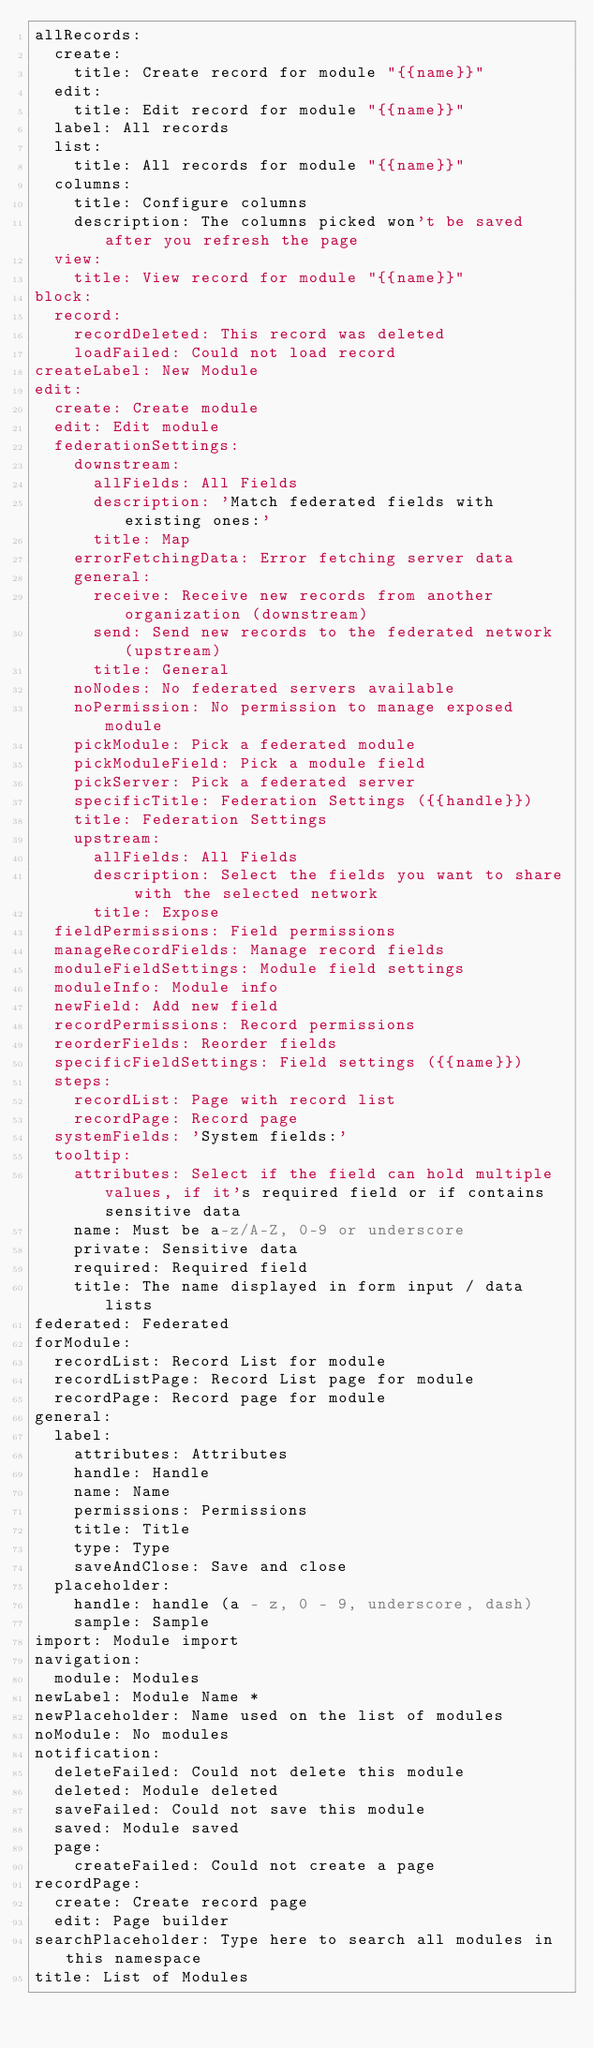<code> <loc_0><loc_0><loc_500><loc_500><_YAML_>allRecords:
  create:
    title: Create record for module "{{name}}"
  edit:
    title: Edit record for module "{{name}}"
  label: All records
  list:
    title: All records for module "{{name}}"
  columns:
    title: Configure columns
    description: The columns picked won't be saved after you refresh the page
  view:
    title: View record for module "{{name}}"
block:
  record:
    recordDeleted: This record was deleted
    loadFailed: Could not load record
createLabel: New Module
edit:
  create: Create module
  edit: Edit module
  federationSettings:
    downstream:
      allFields: All Fields
      description: 'Match federated fields with existing ones:'
      title: Map
    errorFetchingData: Error fetching server data
    general:
      receive: Receive new records from another organization (downstream)
      send: Send new records to the federated network (upstream)
      title: General
    noNodes: No federated servers available
    noPermission: No permission to manage exposed module
    pickModule: Pick a federated module
    pickModuleField: Pick a module field
    pickServer: Pick a federated server
    specificTitle: Federation Settings ({{handle}})
    title: Federation Settings
    upstream:
      allFields: All Fields
      description: Select the fields you want to share with the selected network
      title: Expose
  fieldPermissions: Field permissions
  manageRecordFields: Manage record fields
  moduleFieldSettings: Module field settings
  moduleInfo: Module info
  newField: Add new field
  recordPermissions: Record permissions
  reorderFields: Reorder fields
  specificFieldSettings: Field settings ({{name}})
  steps:
    recordList: Page with record list
    recordPage: Record page
  systemFields: 'System fields:'
  tooltip:
    attributes: Select if the field can hold multiple values, if it's required field or if contains sensitive data
    name: Must be a-z/A-Z, 0-9 or underscore
    private: Sensitive data
    required: Required field
    title: The name displayed in form input / data lists
federated: Federated
forModule:
  recordList: Record List for module
  recordListPage: Record List page for module
  recordPage: Record page for module
general:
  label:
    attributes: Attributes
    handle: Handle
    name: Name
    permissions: Permissions
    title: Title
    type: Type
    saveAndClose: Save and close
  placeholder:
    handle: handle (a - z, 0 - 9, underscore, dash)
    sample: Sample
import: Module import
navigation:
  module: Modules
newLabel: Module Name *
newPlaceholder: Name used on the list of modules
noModule: No modules
notification:
  deleteFailed: Could not delete this module
  deleted: Module deleted
  saveFailed: Could not save this module
  saved: Module saved
  page:
    createFailed: Could not create a page
recordPage:
  create: Create record page
  edit: Page builder
searchPlaceholder: Type here to search all modules in this namespace
title: List of Modules
</code> 